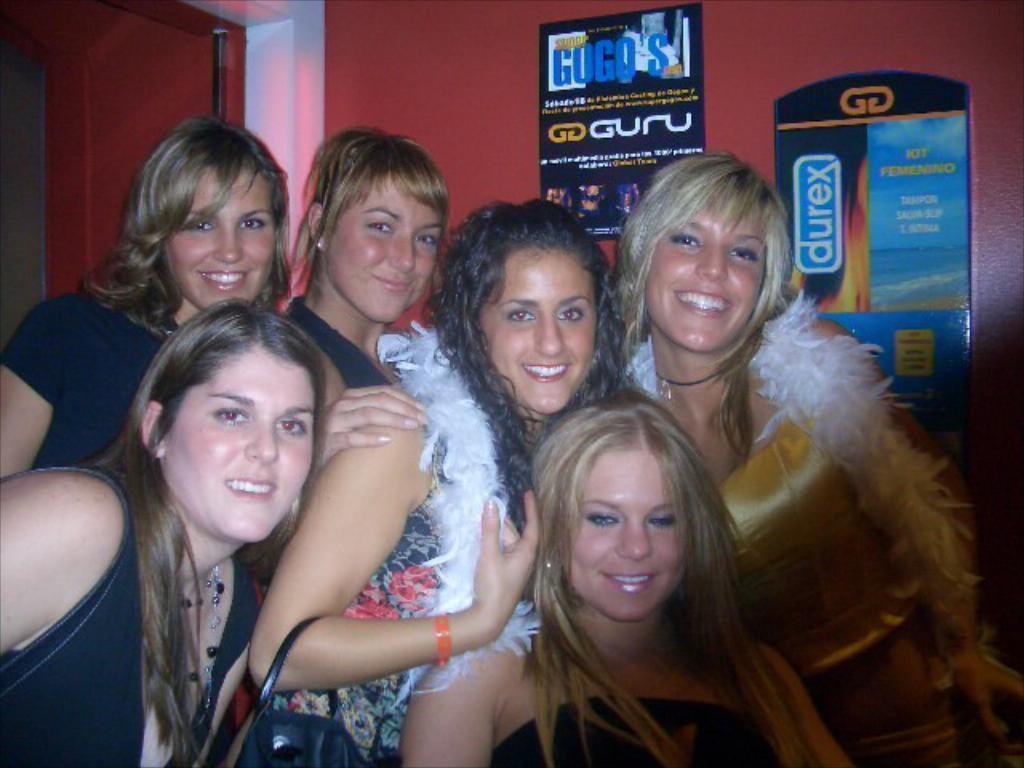Please provide a concise description of this image. In this image I can see the group of people with different color dresses. I can see one person holding the bag. In the background I can see the posts attached to the wall. 